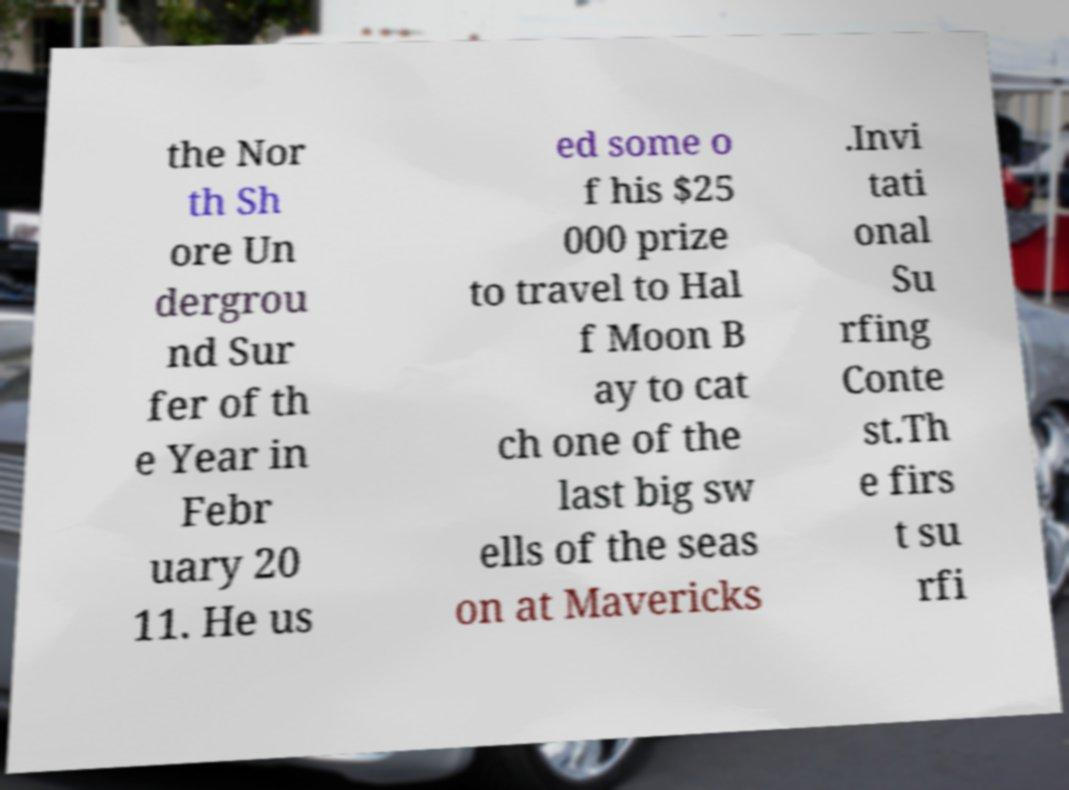For documentation purposes, I need the text within this image transcribed. Could you provide that? the Nor th Sh ore Un dergrou nd Sur fer of th e Year in Febr uary 20 11. He us ed some o f his $25 000 prize to travel to Hal f Moon B ay to cat ch one of the last big sw ells of the seas on at Mavericks .Invi tati onal Su rfing Conte st.Th e firs t su rfi 